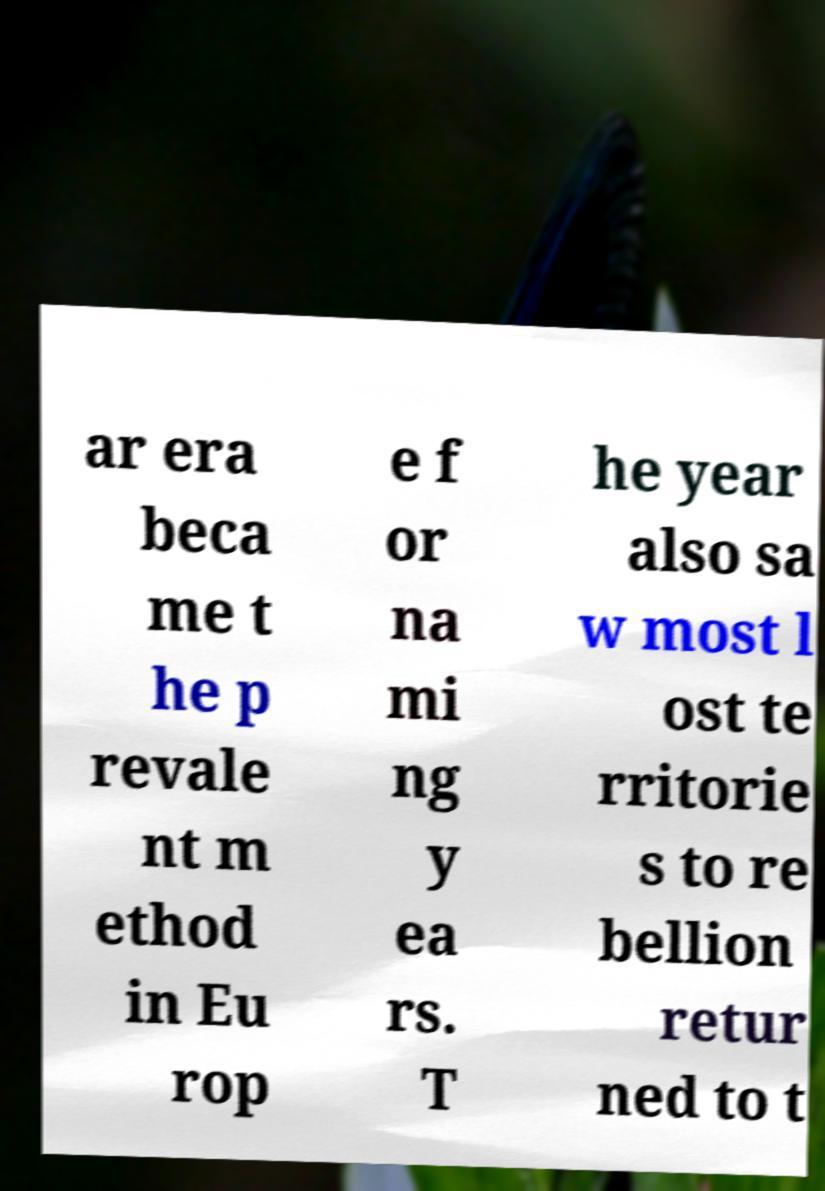For documentation purposes, I need the text within this image transcribed. Could you provide that? ar era beca me t he p revale nt m ethod in Eu rop e f or na mi ng y ea rs. T he year also sa w most l ost te rritorie s to re bellion retur ned to t 